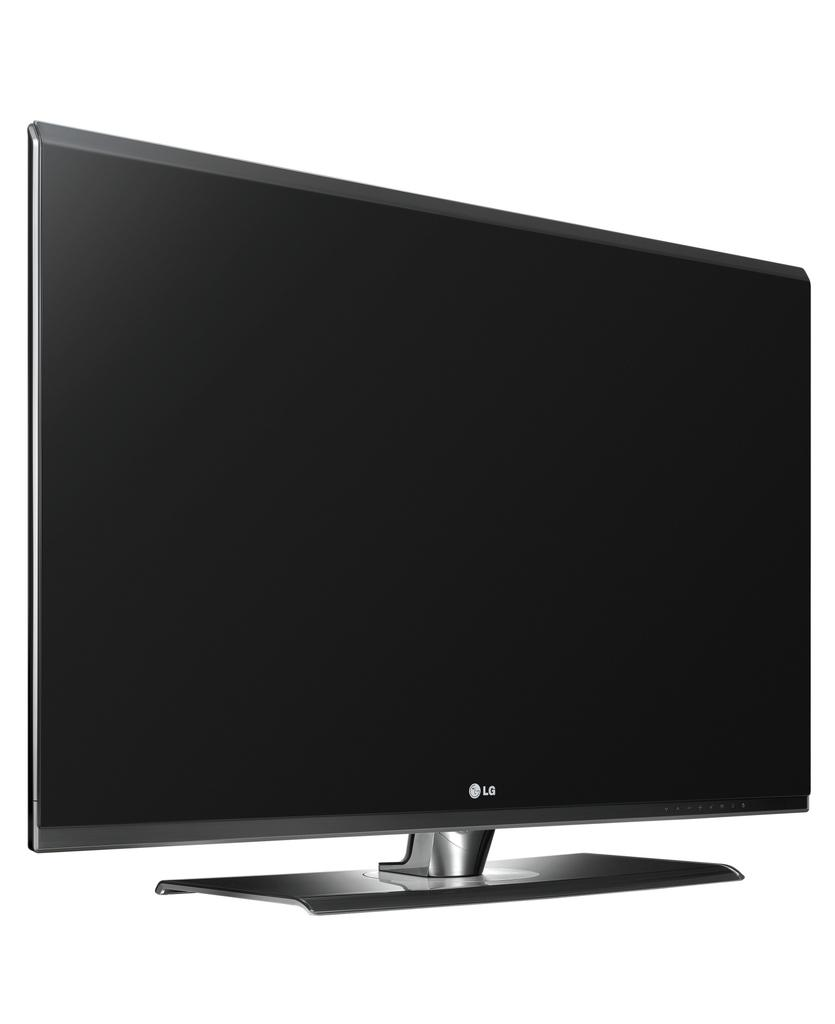What electronic device is present in the image? There is a television in the image. What color is the background of the image? The background of the image is white. How much money is being exchanged in the image? There is no exchange of money depicted in the image; it only features a television and a white background. 